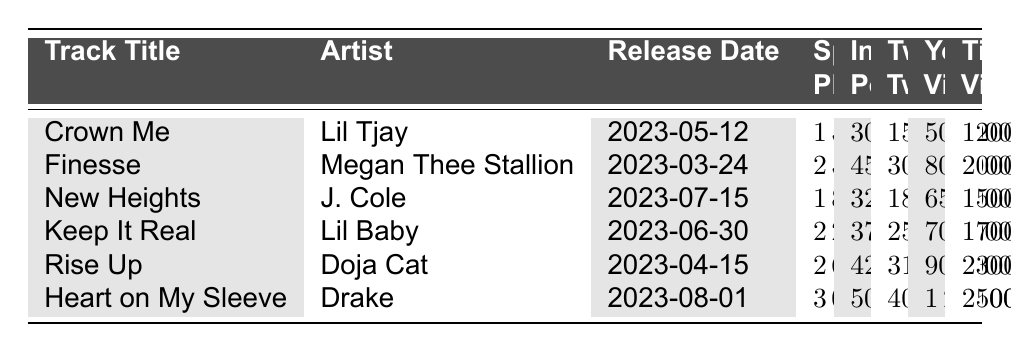What is the highest number of Spotify plays for a track in this table? The highest number of Spotify plays in the table is found by looking through each track's Spotify Plays column. "Heart on My Sleeve" by Drake has 3,000,000 Spotify plays, which is the maximum.
Answer: 3,000,000 Which artist has the most Instagram posts for a track? To find the artist with the most Instagram posts, we need to look at the Instagram Posts column. "Heart on My Sleeve" by Drake has 5,000 posts, which is the greatest amount.
Answer: Drake How many total TikTok videos used the songs from all the tracks in the table? To find the total, we add up the TikTok Videos Using Song for each track: 1200 + 2000 + 1500 + 1700 + 2300 + 2500 = 10200.
Answer: 10,200 Is the number of Twitter tweets for "Finesse" greater than the number for "Keep It Real"? By comparing the Twitter Tweets columns, "Finesse" has 3000 tweets while "Keep It Real" has 2500 tweets, which means Finesse has more.
Answer: Yes What is the average number of YouTube views for the tracks listed? First, we sum the YouTube video views: 500,000 + 800,000 + 650,000 + 700,000 + 900,000 + 1,200,000 = 3,750,000. Dividing by the total number of tracks (6) gives 3,750,000 / 6 = 625,000.
Answer: 625,000 Which track had the highest number of Twitter tweets and how many were there? Examining the Twitter Tweets column, "Heart on My Sleeve" has the highest with 4,000 tweets compared to the others.
Answer: Heart on My Sleeve, 4,000 How many tracks had more than 2,000 TikTok videos using the songs? By checking the TikTok Videos Using Song column, "Finesse," "Rise Up," and "Heart on My Sleeve" have more than 2,000 videos. Therefore, there are 4 tracks total.
Answer: 4 What is the difference in Spotify plays between "Rise Up" and "Keep It Real"? To find the difference, we subtract the Spotify plays for "Keep It Real" (2,200,000) from "Rise Up" (2,600,000): 2,600,000 - 2,200,000 = 400,000.
Answer: 400,000 Which track was released the earliest and how many Spotify plays did it have? Checking the Release Date column, "Finesse" is released on 2023-03-24, earlier than any other track. Its Spotify plays are 2,500,000.
Answer: Finesse, 2,500,000 What percentage of Instagram posts does "Crown Me" represent among all the Instagram posts? First, we calculate total Instagram posts: 3000 + 4500 + 3200 + 3700 + 4200 + 5000 = 22600. "Crown Me" has 3000 posts, so the percentage is (3000 / 22600) * 100 ≈ 13.27%.
Answer: ~13.27% 